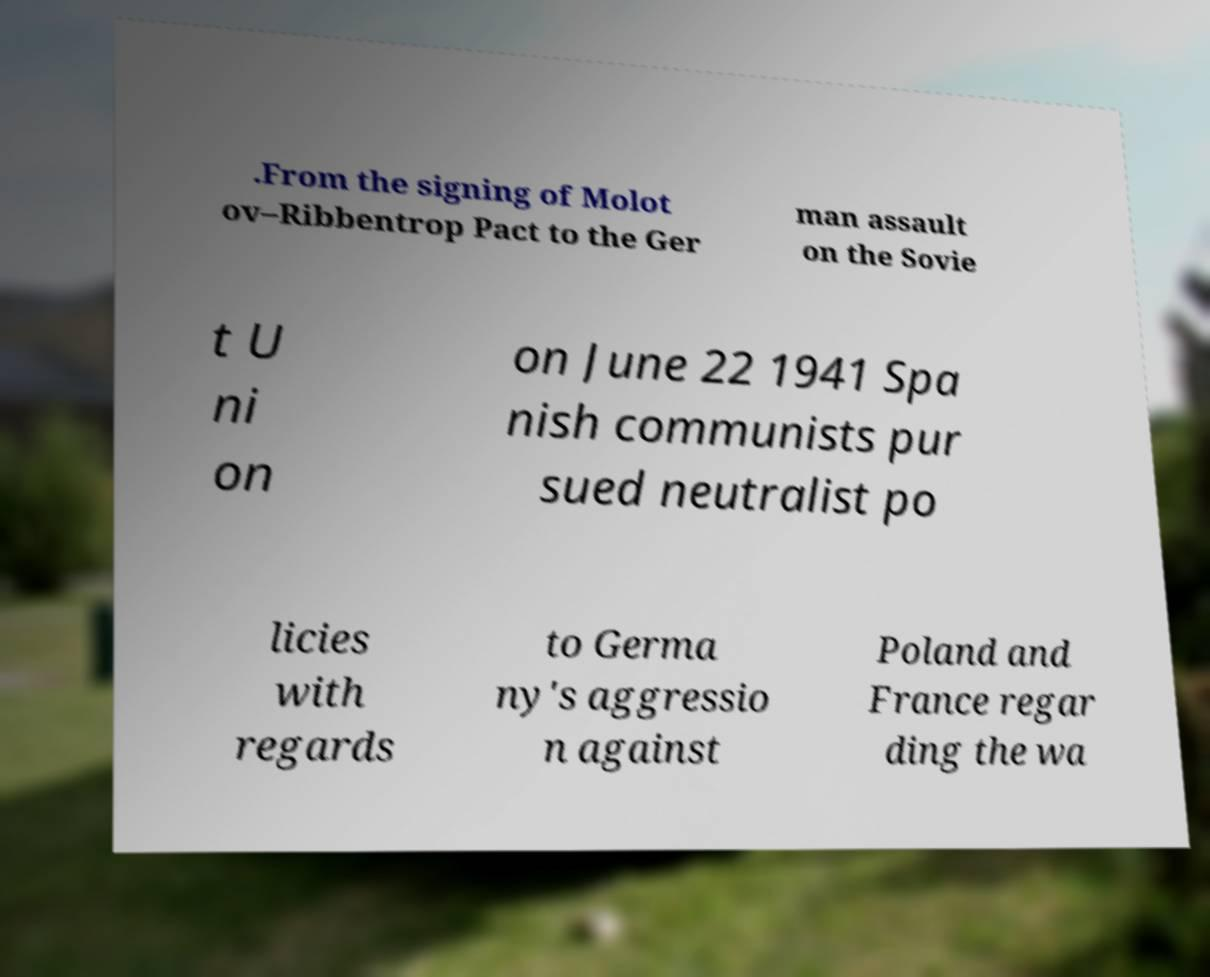There's text embedded in this image that I need extracted. Can you transcribe it verbatim? .From the signing of Molot ov–Ribbentrop Pact to the Ger man assault on the Sovie t U ni on on June 22 1941 Spa nish communists pur sued neutralist po licies with regards to Germa ny's aggressio n against Poland and France regar ding the wa 